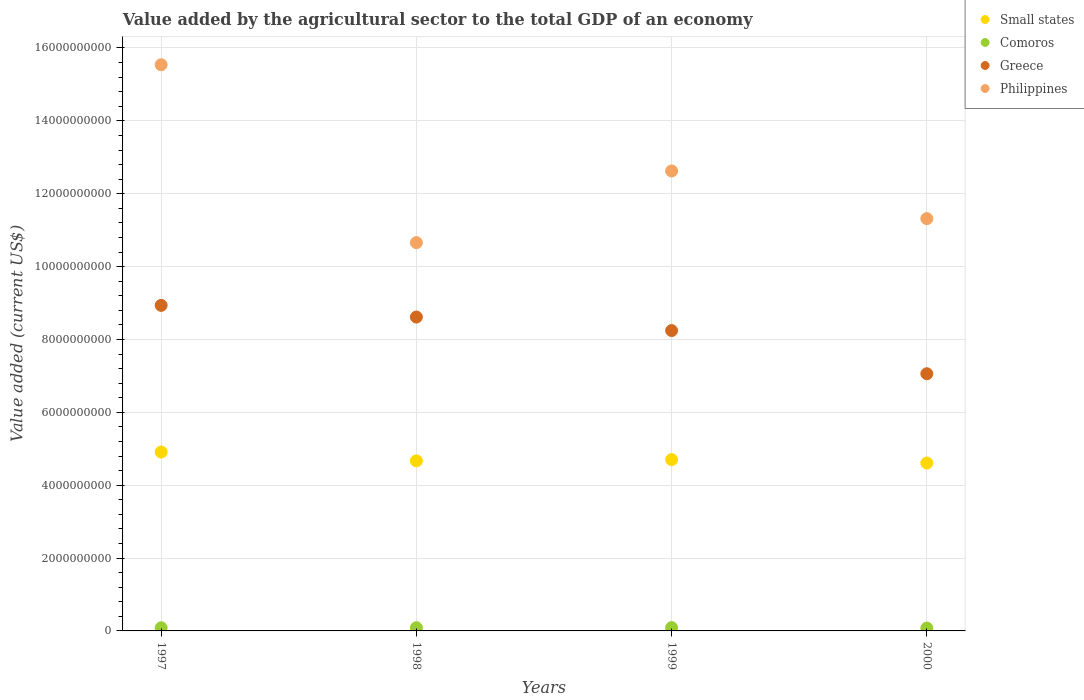What is the value added by the agricultural sector to the total GDP in Philippines in 2000?
Your answer should be very brief. 1.13e+1. Across all years, what is the maximum value added by the agricultural sector to the total GDP in Small states?
Your response must be concise. 4.91e+09. Across all years, what is the minimum value added by the agricultural sector to the total GDP in Philippines?
Keep it short and to the point. 1.07e+1. In which year was the value added by the agricultural sector to the total GDP in Small states maximum?
Your response must be concise. 1997. In which year was the value added by the agricultural sector to the total GDP in Greece minimum?
Your answer should be very brief. 2000. What is the total value added by the agricultural sector to the total GDP in Greece in the graph?
Your answer should be very brief. 3.29e+1. What is the difference between the value added by the agricultural sector to the total GDP in Comoros in 1999 and that in 2000?
Your answer should be very brief. 1.19e+07. What is the difference between the value added by the agricultural sector to the total GDP in Philippines in 1999 and the value added by the agricultural sector to the total GDP in Small states in 2000?
Your response must be concise. 8.02e+09. What is the average value added by the agricultural sector to the total GDP in Comoros per year?
Offer a terse response. 8.63e+07. In the year 1997, what is the difference between the value added by the agricultural sector to the total GDP in Philippines and value added by the agricultural sector to the total GDP in Small states?
Provide a succinct answer. 1.06e+1. What is the ratio of the value added by the agricultural sector to the total GDP in Greece in 1998 to that in 2000?
Provide a short and direct response. 1.22. Is the value added by the agricultural sector to the total GDP in Philippines in 1997 less than that in 2000?
Offer a very short reply. No. What is the difference between the highest and the second highest value added by the agricultural sector to the total GDP in Greece?
Provide a succinct answer. 3.20e+08. What is the difference between the highest and the lowest value added by the agricultural sector to the total GDP in Greece?
Make the answer very short. 1.88e+09. Is the sum of the value added by the agricultural sector to the total GDP in Greece in 1997 and 1998 greater than the maximum value added by the agricultural sector to the total GDP in Small states across all years?
Offer a terse response. Yes. Is it the case that in every year, the sum of the value added by the agricultural sector to the total GDP in Small states and value added by the agricultural sector to the total GDP in Philippines  is greater than the value added by the agricultural sector to the total GDP in Comoros?
Your response must be concise. Yes. Is the value added by the agricultural sector to the total GDP in Small states strictly greater than the value added by the agricultural sector to the total GDP in Philippines over the years?
Make the answer very short. No. Are the values on the major ticks of Y-axis written in scientific E-notation?
Make the answer very short. No. Does the graph contain any zero values?
Your answer should be compact. No. How many legend labels are there?
Your answer should be compact. 4. What is the title of the graph?
Keep it short and to the point. Value added by the agricultural sector to the total GDP of an economy. Does "Ireland" appear as one of the legend labels in the graph?
Keep it short and to the point. No. What is the label or title of the X-axis?
Your answer should be very brief. Years. What is the label or title of the Y-axis?
Ensure brevity in your answer.  Value added (current US$). What is the Value added (current US$) in Small states in 1997?
Make the answer very short. 4.91e+09. What is the Value added (current US$) of Comoros in 1997?
Keep it short and to the point. 8.67e+07. What is the Value added (current US$) of Greece in 1997?
Ensure brevity in your answer.  8.94e+09. What is the Value added (current US$) of Philippines in 1997?
Your answer should be very brief. 1.55e+1. What is the Value added (current US$) in Small states in 1998?
Provide a short and direct response. 4.67e+09. What is the Value added (current US$) in Comoros in 1998?
Provide a short and direct response. 8.82e+07. What is the Value added (current US$) in Greece in 1998?
Keep it short and to the point. 8.62e+09. What is the Value added (current US$) of Philippines in 1998?
Ensure brevity in your answer.  1.07e+1. What is the Value added (current US$) in Small states in 1999?
Offer a very short reply. 4.70e+09. What is the Value added (current US$) in Comoros in 1999?
Offer a terse response. 9.11e+07. What is the Value added (current US$) of Greece in 1999?
Keep it short and to the point. 8.24e+09. What is the Value added (current US$) in Philippines in 1999?
Your answer should be very brief. 1.26e+1. What is the Value added (current US$) of Small states in 2000?
Your answer should be compact. 4.61e+09. What is the Value added (current US$) in Comoros in 2000?
Offer a very short reply. 7.93e+07. What is the Value added (current US$) in Greece in 2000?
Give a very brief answer. 7.06e+09. What is the Value added (current US$) of Philippines in 2000?
Provide a succinct answer. 1.13e+1. Across all years, what is the maximum Value added (current US$) of Small states?
Offer a terse response. 4.91e+09. Across all years, what is the maximum Value added (current US$) in Comoros?
Your answer should be very brief. 9.11e+07. Across all years, what is the maximum Value added (current US$) in Greece?
Your answer should be compact. 8.94e+09. Across all years, what is the maximum Value added (current US$) of Philippines?
Give a very brief answer. 1.55e+1. Across all years, what is the minimum Value added (current US$) of Small states?
Your response must be concise. 4.61e+09. Across all years, what is the minimum Value added (current US$) of Comoros?
Ensure brevity in your answer.  7.93e+07. Across all years, what is the minimum Value added (current US$) in Greece?
Ensure brevity in your answer.  7.06e+09. Across all years, what is the minimum Value added (current US$) in Philippines?
Provide a short and direct response. 1.07e+1. What is the total Value added (current US$) in Small states in the graph?
Offer a very short reply. 1.89e+1. What is the total Value added (current US$) in Comoros in the graph?
Give a very brief answer. 3.45e+08. What is the total Value added (current US$) of Greece in the graph?
Provide a short and direct response. 3.29e+1. What is the total Value added (current US$) in Philippines in the graph?
Keep it short and to the point. 5.01e+1. What is the difference between the Value added (current US$) of Small states in 1997 and that in 1998?
Give a very brief answer. 2.42e+08. What is the difference between the Value added (current US$) in Comoros in 1997 and that in 1998?
Your answer should be very brief. -1.42e+06. What is the difference between the Value added (current US$) in Greece in 1997 and that in 1998?
Ensure brevity in your answer.  3.20e+08. What is the difference between the Value added (current US$) of Philippines in 1997 and that in 1998?
Provide a short and direct response. 4.88e+09. What is the difference between the Value added (current US$) of Small states in 1997 and that in 1999?
Offer a very short reply. 2.07e+08. What is the difference between the Value added (current US$) in Comoros in 1997 and that in 1999?
Make the answer very short. -4.41e+06. What is the difference between the Value added (current US$) of Greece in 1997 and that in 1999?
Provide a short and direct response. 6.92e+08. What is the difference between the Value added (current US$) in Philippines in 1997 and that in 1999?
Your answer should be compact. 2.92e+09. What is the difference between the Value added (current US$) of Small states in 1997 and that in 2000?
Offer a very short reply. 3.00e+08. What is the difference between the Value added (current US$) of Comoros in 1997 and that in 2000?
Offer a terse response. 7.45e+06. What is the difference between the Value added (current US$) of Greece in 1997 and that in 2000?
Make the answer very short. 1.88e+09. What is the difference between the Value added (current US$) of Philippines in 1997 and that in 2000?
Your answer should be very brief. 4.22e+09. What is the difference between the Value added (current US$) of Small states in 1998 and that in 1999?
Your response must be concise. -3.50e+07. What is the difference between the Value added (current US$) of Comoros in 1998 and that in 1999?
Your response must be concise. -2.99e+06. What is the difference between the Value added (current US$) in Greece in 1998 and that in 1999?
Offer a very short reply. 3.71e+08. What is the difference between the Value added (current US$) of Philippines in 1998 and that in 1999?
Your response must be concise. -1.97e+09. What is the difference between the Value added (current US$) of Small states in 1998 and that in 2000?
Make the answer very short. 5.81e+07. What is the difference between the Value added (current US$) in Comoros in 1998 and that in 2000?
Provide a succinct answer. 8.87e+06. What is the difference between the Value added (current US$) in Greece in 1998 and that in 2000?
Ensure brevity in your answer.  1.56e+09. What is the difference between the Value added (current US$) of Philippines in 1998 and that in 2000?
Keep it short and to the point. -6.59e+08. What is the difference between the Value added (current US$) of Small states in 1999 and that in 2000?
Give a very brief answer. 9.31e+07. What is the difference between the Value added (current US$) of Comoros in 1999 and that in 2000?
Provide a short and direct response. 1.19e+07. What is the difference between the Value added (current US$) of Greece in 1999 and that in 2000?
Ensure brevity in your answer.  1.18e+09. What is the difference between the Value added (current US$) in Philippines in 1999 and that in 2000?
Offer a very short reply. 1.31e+09. What is the difference between the Value added (current US$) in Small states in 1997 and the Value added (current US$) in Comoros in 1998?
Give a very brief answer. 4.82e+09. What is the difference between the Value added (current US$) in Small states in 1997 and the Value added (current US$) in Greece in 1998?
Provide a succinct answer. -3.71e+09. What is the difference between the Value added (current US$) of Small states in 1997 and the Value added (current US$) of Philippines in 1998?
Provide a short and direct response. -5.75e+09. What is the difference between the Value added (current US$) in Comoros in 1997 and the Value added (current US$) in Greece in 1998?
Provide a succinct answer. -8.53e+09. What is the difference between the Value added (current US$) in Comoros in 1997 and the Value added (current US$) in Philippines in 1998?
Ensure brevity in your answer.  -1.06e+1. What is the difference between the Value added (current US$) in Greece in 1997 and the Value added (current US$) in Philippines in 1998?
Your answer should be compact. -1.72e+09. What is the difference between the Value added (current US$) of Small states in 1997 and the Value added (current US$) of Comoros in 1999?
Offer a terse response. 4.82e+09. What is the difference between the Value added (current US$) of Small states in 1997 and the Value added (current US$) of Greece in 1999?
Provide a short and direct response. -3.33e+09. What is the difference between the Value added (current US$) of Small states in 1997 and the Value added (current US$) of Philippines in 1999?
Provide a succinct answer. -7.71e+09. What is the difference between the Value added (current US$) in Comoros in 1997 and the Value added (current US$) in Greece in 1999?
Make the answer very short. -8.16e+09. What is the difference between the Value added (current US$) of Comoros in 1997 and the Value added (current US$) of Philippines in 1999?
Offer a terse response. -1.25e+1. What is the difference between the Value added (current US$) in Greece in 1997 and the Value added (current US$) in Philippines in 1999?
Ensure brevity in your answer.  -3.69e+09. What is the difference between the Value added (current US$) of Small states in 1997 and the Value added (current US$) of Comoros in 2000?
Provide a succinct answer. 4.83e+09. What is the difference between the Value added (current US$) of Small states in 1997 and the Value added (current US$) of Greece in 2000?
Provide a succinct answer. -2.15e+09. What is the difference between the Value added (current US$) in Small states in 1997 and the Value added (current US$) in Philippines in 2000?
Make the answer very short. -6.41e+09. What is the difference between the Value added (current US$) of Comoros in 1997 and the Value added (current US$) of Greece in 2000?
Ensure brevity in your answer.  -6.97e+09. What is the difference between the Value added (current US$) in Comoros in 1997 and the Value added (current US$) in Philippines in 2000?
Offer a very short reply. -1.12e+1. What is the difference between the Value added (current US$) in Greece in 1997 and the Value added (current US$) in Philippines in 2000?
Your response must be concise. -2.38e+09. What is the difference between the Value added (current US$) of Small states in 1998 and the Value added (current US$) of Comoros in 1999?
Your response must be concise. 4.58e+09. What is the difference between the Value added (current US$) in Small states in 1998 and the Value added (current US$) in Greece in 1999?
Keep it short and to the point. -3.58e+09. What is the difference between the Value added (current US$) of Small states in 1998 and the Value added (current US$) of Philippines in 1999?
Offer a very short reply. -7.96e+09. What is the difference between the Value added (current US$) of Comoros in 1998 and the Value added (current US$) of Greece in 1999?
Your answer should be compact. -8.16e+09. What is the difference between the Value added (current US$) of Comoros in 1998 and the Value added (current US$) of Philippines in 1999?
Your response must be concise. -1.25e+1. What is the difference between the Value added (current US$) in Greece in 1998 and the Value added (current US$) in Philippines in 1999?
Give a very brief answer. -4.01e+09. What is the difference between the Value added (current US$) in Small states in 1998 and the Value added (current US$) in Comoros in 2000?
Provide a succinct answer. 4.59e+09. What is the difference between the Value added (current US$) of Small states in 1998 and the Value added (current US$) of Greece in 2000?
Make the answer very short. -2.39e+09. What is the difference between the Value added (current US$) in Small states in 1998 and the Value added (current US$) in Philippines in 2000?
Your answer should be very brief. -6.65e+09. What is the difference between the Value added (current US$) of Comoros in 1998 and the Value added (current US$) of Greece in 2000?
Keep it short and to the point. -6.97e+09. What is the difference between the Value added (current US$) of Comoros in 1998 and the Value added (current US$) of Philippines in 2000?
Provide a short and direct response. -1.12e+1. What is the difference between the Value added (current US$) of Greece in 1998 and the Value added (current US$) of Philippines in 2000?
Provide a short and direct response. -2.70e+09. What is the difference between the Value added (current US$) of Small states in 1999 and the Value added (current US$) of Comoros in 2000?
Keep it short and to the point. 4.62e+09. What is the difference between the Value added (current US$) in Small states in 1999 and the Value added (current US$) in Greece in 2000?
Offer a terse response. -2.36e+09. What is the difference between the Value added (current US$) of Small states in 1999 and the Value added (current US$) of Philippines in 2000?
Offer a very short reply. -6.61e+09. What is the difference between the Value added (current US$) in Comoros in 1999 and the Value added (current US$) in Greece in 2000?
Provide a succinct answer. -6.97e+09. What is the difference between the Value added (current US$) in Comoros in 1999 and the Value added (current US$) in Philippines in 2000?
Give a very brief answer. -1.12e+1. What is the difference between the Value added (current US$) in Greece in 1999 and the Value added (current US$) in Philippines in 2000?
Your response must be concise. -3.07e+09. What is the average Value added (current US$) in Small states per year?
Provide a short and direct response. 4.72e+09. What is the average Value added (current US$) of Comoros per year?
Your response must be concise. 8.63e+07. What is the average Value added (current US$) in Greece per year?
Your response must be concise. 8.21e+09. What is the average Value added (current US$) of Philippines per year?
Your response must be concise. 1.25e+1. In the year 1997, what is the difference between the Value added (current US$) in Small states and Value added (current US$) in Comoros?
Your answer should be very brief. 4.82e+09. In the year 1997, what is the difference between the Value added (current US$) of Small states and Value added (current US$) of Greece?
Ensure brevity in your answer.  -4.03e+09. In the year 1997, what is the difference between the Value added (current US$) of Small states and Value added (current US$) of Philippines?
Your response must be concise. -1.06e+1. In the year 1997, what is the difference between the Value added (current US$) in Comoros and Value added (current US$) in Greece?
Offer a terse response. -8.85e+09. In the year 1997, what is the difference between the Value added (current US$) in Comoros and Value added (current US$) in Philippines?
Make the answer very short. -1.55e+1. In the year 1997, what is the difference between the Value added (current US$) in Greece and Value added (current US$) in Philippines?
Provide a succinct answer. -6.60e+09. In the year 1998, what is the difference between the Value added (current US$) of Small states and Value added (current US$) of Comoros?
Keep it short and to the point. 4.58e+09. In the year 1998, what is the difference between the Value added (current US$) of Small states and Value added (current US$) of Greece?
Keep it short and to the point. -3.95e+09. In the year 1998, what is the difference between the Value added (current US$) in Small states and Value added (current US$) in Philippines?
Your answer should be very brief. -5.99e+09. In the year 1998, what is the difference between the Value added (current US$) in Comoros and Value added (current US$) in Greece?
Make the answer very short. -8.53e+09. In the year 1998, what is the difference between the Value added (current US$) of Comoros and Value added (current US$) of Philippines?
Give a very brief answer. -1.06e+1. In the year 1998, what is the difference between the Value added (current US$) in Greece and Value added (current US$) in Philippines?
Your answer should be compact. -2.04e+09. In the year 1999, what is the difference between the Value added (current US$) in Small states and Value added (current US$) in Comoros?
Your answer should be compact. 4.61e+09. In the year 1999, what is the difference between the Value added (current US$) of Small states and Value added (current US$) of Greece?
Give a very brief answer. -3.54e+09. In the year 1999, what is the difference between the Value added (current US$) of Small states and Value added (current US$) of Philippines?
Offer a terse response. -7.92e+09. In the year 1999, what is the difference between the Value added (current US$) of Comoros and Value added (current US$) of Greece?
Ensure brevity in your answer.  -8.15e+09. In the year 1999, what is the difference between the Value added (current US$) in Comoros and Value added (current US$) in Philippines?
Offer a very short reply. -1.25e+1. In the year 1999, what is the difference between the Value added (current US$) of Greece and Value added (current US$) of Philippines?
Offer a very short reply. -4.38e+09. In the year 2000, what is the difference between the Value added (current US$) of Small states and Value added (current US$) of Comoros?
Your answer should be very brief. 4.53e+09. In the year 2000, what is the difference between the Value added (current US$) in Small states and Value added (current US$) in Greece?
Give a very brief answer. -2.45e+09. In the year 2000, what is the difference between the Value added (current US$) in Small states and Value added (current US$) in Philippines?
Give a very brief answer. -6.71e+09. In the year 2000, what is the difference between the Value added (current US$) of Comoros and Value added (current US$) of Greece?
Offer a terse response. -6.98e+09. In the year 2000, what is the difference between the Value added (current US$) in Comoros and Value added (current US$) in Philippines?
Your answer should be compact. -1.12e+1. In the year 2000, what is the difference between the Value added (current US$) of Greece and Value added (current US$) of Philippines?
Make the answer very short. -4.26e+09. What is the ratio of the Value added (current US$) of Small states in 1997 to that in 1998?
Ensure brevity in your answer.  1.05. What is the ratio of the Value added (current US$) of Comoros in 1997 to that in 1998?
Ensure brevity in your answer.  0.98. What is the ratio of the Value added (current US$) of Greece in 1997 to that in 1998?
Keep it short and to the point. 1.04. What is the ratio of the Value added (current US$) in Philippines in 1997 to that in 1998?
Give a very brief answer. 1.46. What is the ratio of the Value added (current US$) of Small states in 1997 to that in 1999?
Provide a succinct answer. 1.04. What is the ratio of the Value added (current US$) in Comoros in 1997 to that in 1999?
Give a very brief answer. 0.95. What is the ratio of the Value added (current US$) of Greece in 1997 to that in 1999?
Offer a very short reply. 1.08. What is the ratio of the Value added (current US$) of Philippines in 1997 to that in 1999?
Ensure brevity in your answer.  1.23. What is the ratio of the Value added (current US$) of Small states in 1997 to that in 2000?
Your answer should be compact. 1.07. What is the ratio of the Value added (current US$) of Comoros in 1997 to that in 2000?
Your answer should be compact. 1.09. What is the ratio of the Value added (current US$) of Greece in 1997 to that in 2000?
Give a very brief answer. 1.27. What is the ratio of the Value added (current US$) of Philippines in 1997 to that in 2000?
Give a very brief answer. 1.37. What is the ratio of the Value added (current US$) in Small states in 1998 to that in 1999?
Your response must be concise. 0.99. What is the ratio of the Value added (current US$) in Comoros in 1998 to that in 1999?
Provide a short and direct response. 0.97. What is the ratio of the Value added (current US$) in Greece in 1998 to that in 1999?
Your response must be concise. 1.04. What is the ratio of the Value added (current US$) in Philippines in 1998 to that in 1999?
Give a very brief answer. 0.84. What is the ratio of the Value added (current US$) of Small states in 1998 to that in 2000?
Your answer should be very brief. 1.01. What is the ratio of the Value added (current US$) in Comoros in 1998 to that in 2000?
Give a very brief answer. 1.11. What is the ratio of the Value added (current US$) of Greece in 1998 to that in 2000?
Your answer should be compact. 1.22. What is the ratio of the Value added (current US$) of Philippines in 1998 to that in 2000?
Make the answer very short. 0.94. What is the ratio of the Value added (current US$) in Small states in 1999 to that in 2000?
Offer a very short reply. 1.02. What is the ratio of the Value added (current US$) of Comoros in 1999 to that in 2000?
Your response must be concise. 1.15. What is the ratio of the Value added (current US$) of Greece in 1999 to that in 2000?
Give a very brief answer. 1.17. What is the ratio of the Value added (current US$) of Philippines in 1999 to that in 2000?
Your answer should be very brief. 1.12. What is the difference between the highest and the second highest Value added (current US$) of Small states?
Offer a very short reply. 2.07e+08. What is the difference between the highest and the second highest Value added (current US$) in Comoros?
Offer a terse response. 2.99e+06. What is the difference between the highest and the second highest Value added (current US$) in Greece?
Your answer should be compact. 3.20e+08. What is the difference between the highest and the second highest Value added (current US$) in Philippines?
Offer a very short reply. 2.92e+09. What is the difference between the highest and the lowest Value added (current US$) in Small states?
Keep it short and to the point. 3.00e+08. What is the difference between the highest and the lowest Value added (current US$) of Comoros?
Keep it short and to the point. 1.19e+07. What is the difference between the highest and the lowest Value added (current US$) of Greece?
Your response must be concise. 1.88e+09. What is the difference between the highest and the lowest Value added (current US$) in Philippines?
Your answer should be very brief. 4.88e+09. 